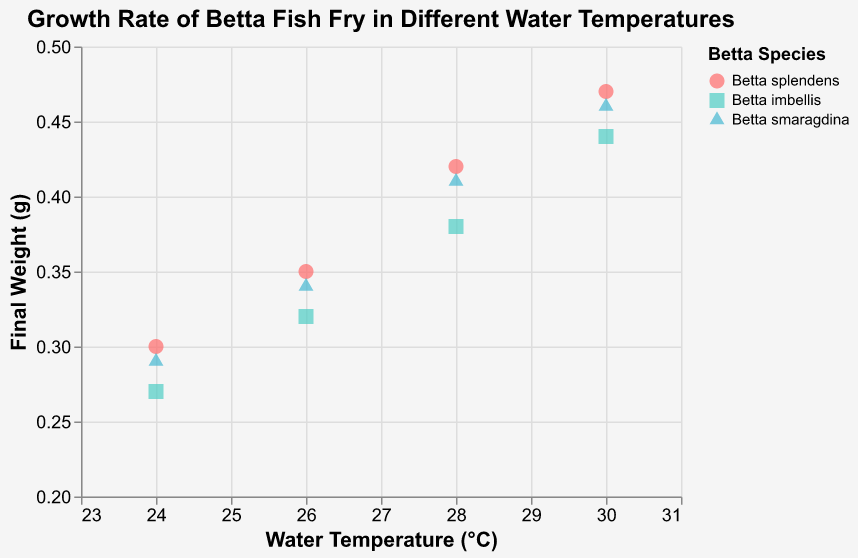How does the final weight of Betta splendens change with water temperature? As the water temperature increases from 24°C to 30°C, the final weight of Betta splendens increases. At 24°C, the final weight is 0.3g, at 26°C it is 0.35g, at 28°C it is 0.42g, and at 30°C it is 0.47g.
Answer: The final weight increases with temperature Which Betta species achieves the highest final weight at 28°C? At 28°C, the final weights are: Betta splendens (0.42g), Betta imbellis (0.38g), and Betta smaragdina (0.41g). Betta splendens has the highest final weight.
Answer: Betta splendens What is the overall trend in the final weight of Betta imbellis as the water temperature increases? The final weight of Betta imbellis increases with the water temperature. At 24°C, the final weight is 0.27g, at 26°C it is 0.32g, at 28°C it is 0.38g, and at 30°C it is 0.44g.
Answer: The final weight increases with temperature How does Betta smaragdina compare to Betta imbellis at 30°C? At 30°C, Betta smaragdina's final weight is 0.46g, while Betta imbellis' final weight is 0.44g. Betta smaragdina has a slightly higher final weight than Betta imbellis.
Answer: Betta smaragdina has a higher final weight Is there any species that shows a decreasing trend in final weight with increasing water temperature? No, all species (Betta splendens, Betta imbellis, Betta smaragdina) show an increasing trend in final weight with increasing water temperature.
Answer: No What's the average final weight of Betta splendens across all temperatures? To find the average final weight, sum all the final weights of Betta splendens (0.3 + 0.35 + 0.42 + 0.47) and divide by the number of data points (4): (0.3 + 0.35 + 0.42 + 0.47) / 4 = 1.54 / 4 = 0.385g.
Answer: 0.385g Which species has the least variation in final weight across different temperatures? To determine this, compare the range of final weights for each species: Betta splendens (0.47 - 0.3 = 0.17), Betta imbellis (0.44 - 0.27 = 0.17), Betta smaragdina (0.46 - 0.29 = 0.17). All species have the same range of 0.17g.
Answer: All species have the same range What is the increase in final weight for Betta smaragdina from 24°C to 30°C? The final weight at 24°C for Betta smaragdina is 0.29g, and at 30°C it is 0.46g. The increase is 0.46g - 0.29g = 0.17g.
Answer: 0.17g At which temperature is the final weight of Betta imbellis closest to the final weight of Betta splendens? Compare the final weights at each temperature: 24°C (0.27g vs. 0.3g, difference = 0.03g), 26°C (0.32g vs. 0.35g, difference = 0.03g), 28°C (0.38g vs. 0.42g, difference = 0.04g), 30°C (0.44g vs. 0.47g, difference = 0.03g). The final weights are closest at 24°C, 26°C, and 30°C with a difference of 0.03g.
Answer: 24°C, 26°C, and 30°C 